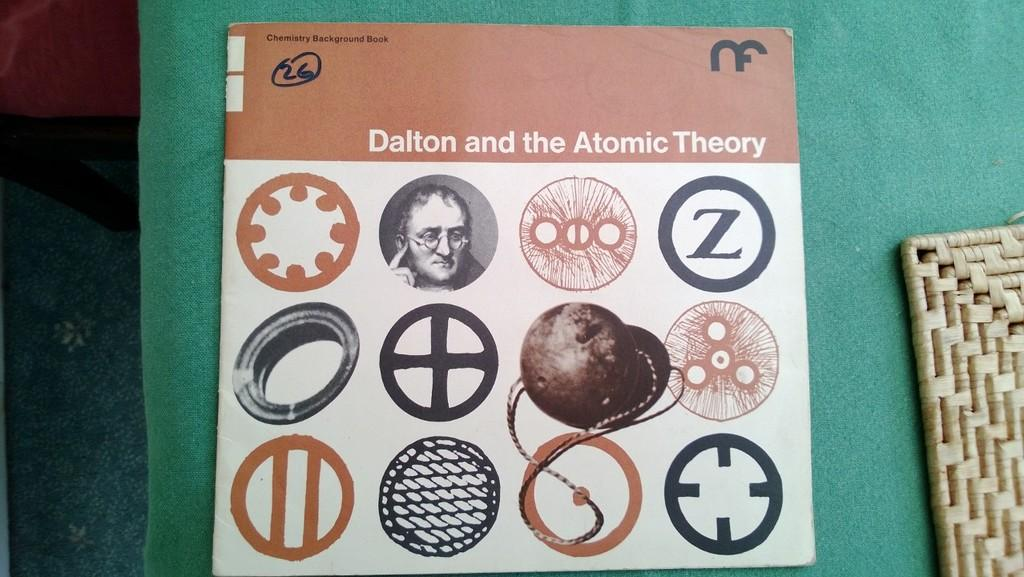What can be seen on the poster in the image? Unfortunately, the provided facts do not give any information about the content of the poster. What type of shock can be seen affecting the objects in the image? There is no indication of any shock or battle in the image; it only shows a poster and objects. Is there any driving activity taking place in the image? There is no driving activity present in the image. 